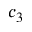Convert formula to latex. <formula><loc_0><loc_0><loc_500><loc_500>c _ { 3 }</formula> 